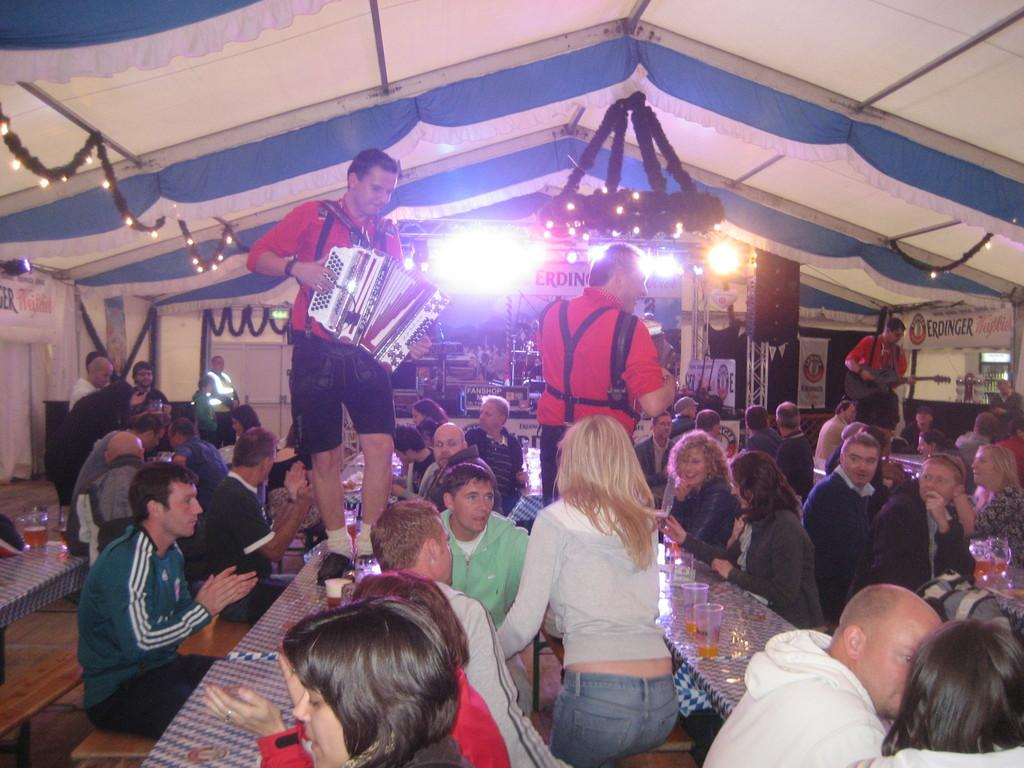How many people are in the image? There are people in the image, but the exact number is not specified. What are some of the people doing in the image? Some people are sitting, and some people are standing. What objects are in front of the people? There are tables in front of the people. What type of pen is being used by the person sitting at the table? There is no pen visible in the image, so it cannot be determined what type of pen might be used. 